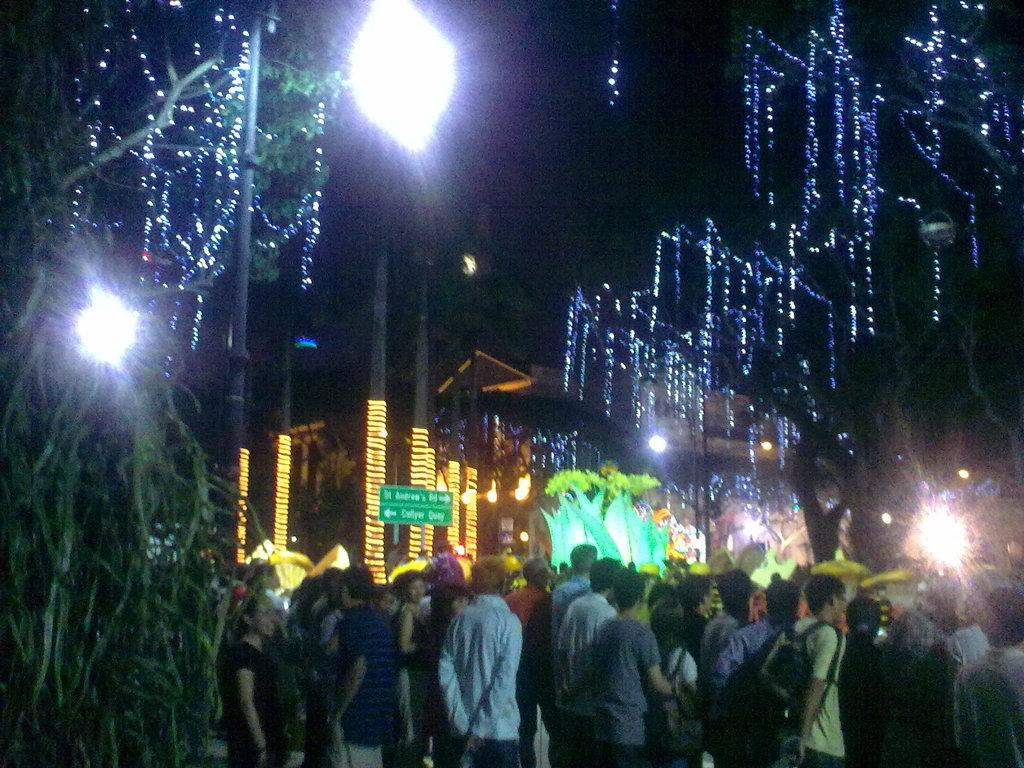What type of structure is visible in the image? There is a building in the image. What feature is present on the building? The building has lighting. Are there any other elements with lighting in the image? Yes, there are trees with lighting in the image. Can you describe the people in the image? There are people standing in the image. What type of flower is in the vase on the building's balcony in the image? There is no vase or flower present on the building's balcony in the image. 